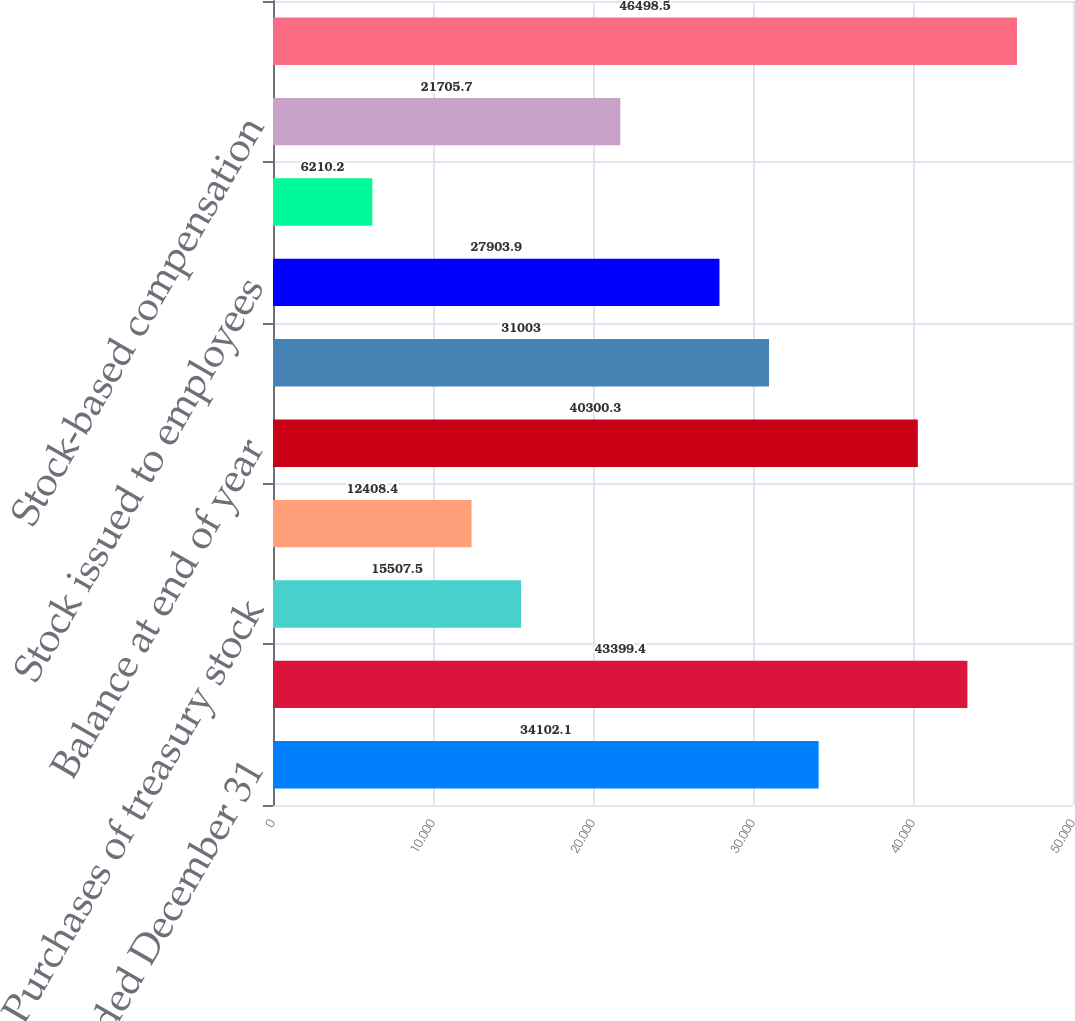Convert chart to OTSL. <chart><loc_0><loc_0><loc_500><loc_500><bar_chart><fcel>Year Ended December 31<fcel>Balance at beginning of year<fcel>Purchases of treasury stock<fcel>Treasury stock issued to<fcel>Balance at end of year<fcel>COMMON STOCK<fcel>Stock issued to employees<fcel>Tax benefit (charge) from<fcel>Stock-based compensation<fcel>Net income attributable to<nl><fcel>34102.1<fcel>43399.4<fcel>15507.5<fcel>12408.4<fcel>40300.3<fcel>31003<fcel>27903.9<fcel>6210.2<fcel>21705.7<fcel>46498.5<nl></chart> 